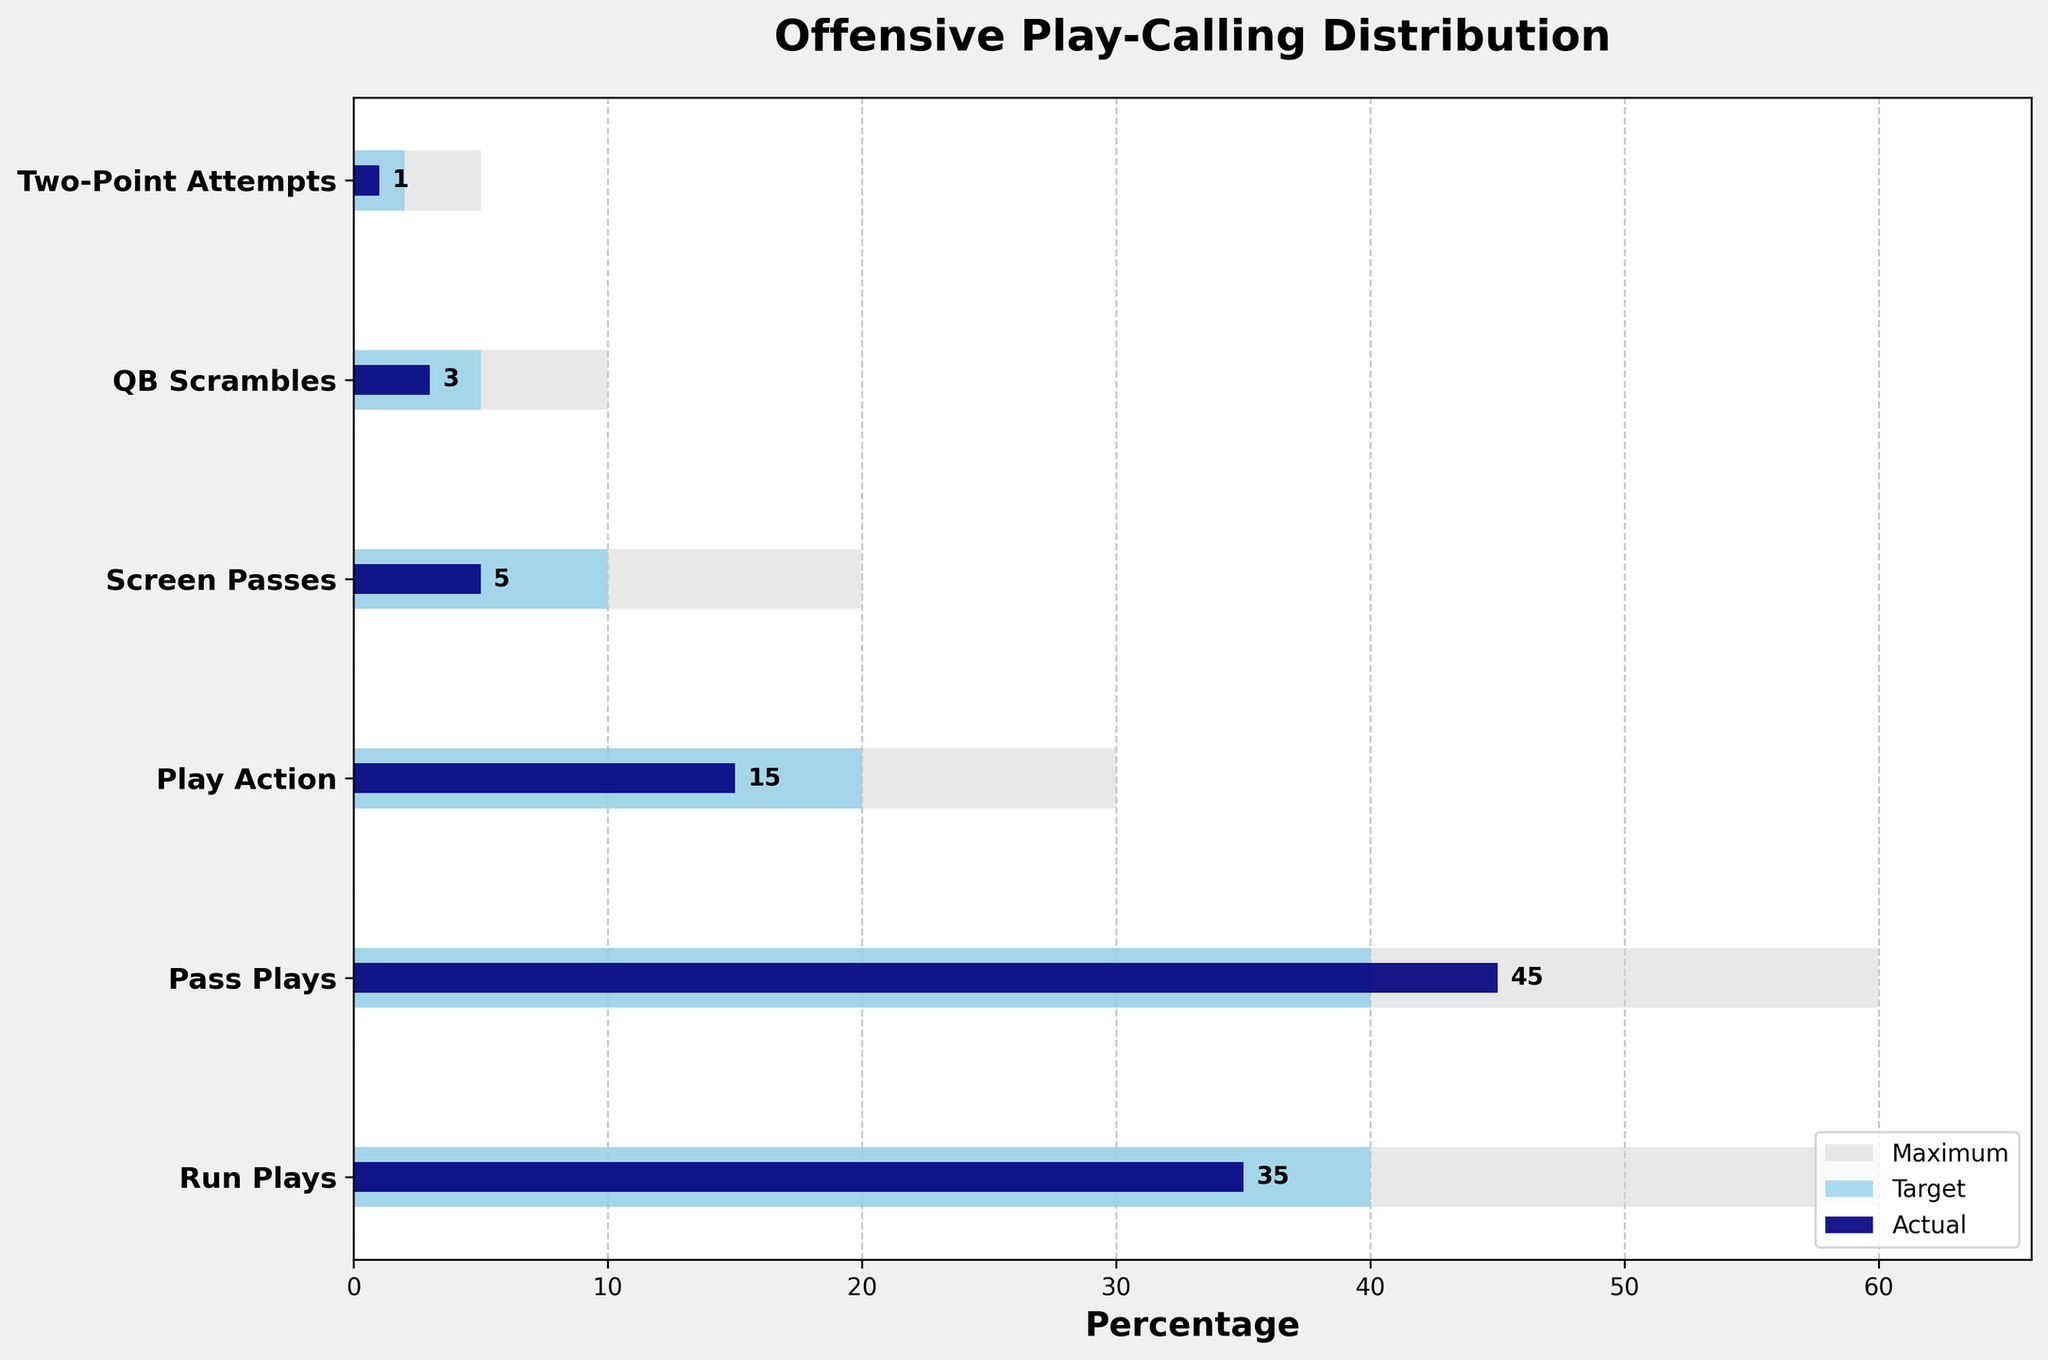What is the title of the chart? The title of the chart is clearly stated at the top of the figure.
Answer: Offensive Play-Calling Distribution What's the value of actual Run Plays? The value is represented by the smallest bar in dark navy color corresponding to Run Plays.
Answer: 35 How many different play types are shown in the figure? Count the number of distinct categories listed on the y-axis.
Answer: 6 Which play type has the highest actual percentage? Compare the lengths of the navy-colored "Actual" bars; the longest represents the highest value.
Answer: Pass Plays How does the target value for Screen Passes compare to the actual value? Look at the two bars for Screen Passes: the "Target" bar (skyblue) and the "Actual" bar (navy).
Answer: The target (10) is double the actual (5) What is the difference between the maximum and actual values for QB Scrambles? Subtract the actual value for QB Scrambles from the maximum value for QB Scrambles: 10 - 3.
Answer: 7 Is the actual percentage for Play Action closer to the target or the maximum? Compare the actual (navy) bar length with the target (skyblue) and maximum (lightgrey) for Play Action.
Answer: Closer to target For which play type is the actual percentage the same as the target percentage? Cross-check the dark navy "Actual" bar lengths with the skyblue "Target" bars to find any matching lengths.
Answer: Pass Plays Compare the sum of actual percentages for Play Action and Screen Passes to the maximum value for Run Plays. Which is higher? Add the actual values for Play Action (15) and Screen Passes (5), then compare the sum to the maximum value for Run Plays (60).
Answer: Sum (20) is less than max Run Plays (60) What's the average actual percentage across all play types? Sum all actual values (35+45+15+5+3+1) and divide by the number of play types (6).
Answer: 17.33 